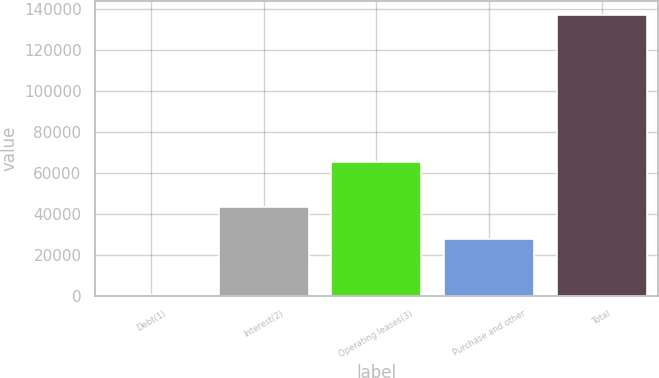Convert chart to OTSL. <chart><loc_0><loc_0><loc_500><loc_500><bar_chart><fcel>Debt(1)<fcel>Interest(2)<fcel>Operating leases(3)<fcel>Purchase and other<fcel>Total<nl><fcel>648<fcel>43439<fcel>65088<fcel>27693<fcel>136868<nl></chart> 